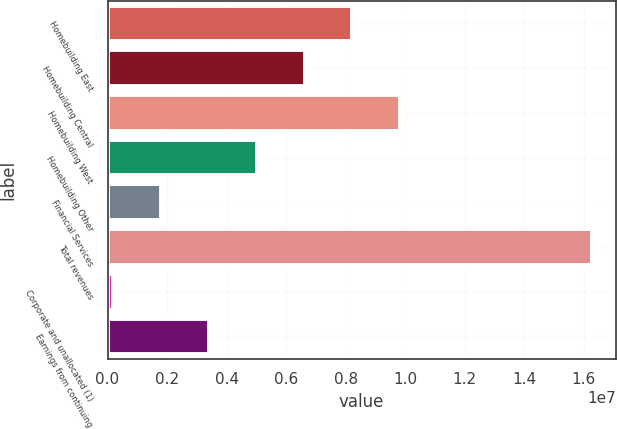Convert chart to OTSL. <chart><loc_0><loc_0><loc_500><loc_500><bar_chart><fcel>Homebuilding East<fcel>Homebuilding Central<fcel>Homebuilding West<fcel>Homebuilding Other<fcel>Financial Services<fcel>Total revenues<fcel>Corporate and unallocated (1)<fcel>Earnings from continuing<nl><fcel>8.22998e+06<fcel>6.62265e+06<fcel>9.83732e+06<fcel>5.01531e+06<fcel>1.80064e+06<fcel>1.62667e+07<fcel>193307<fcel>3.40798e+06<nl></chart> 